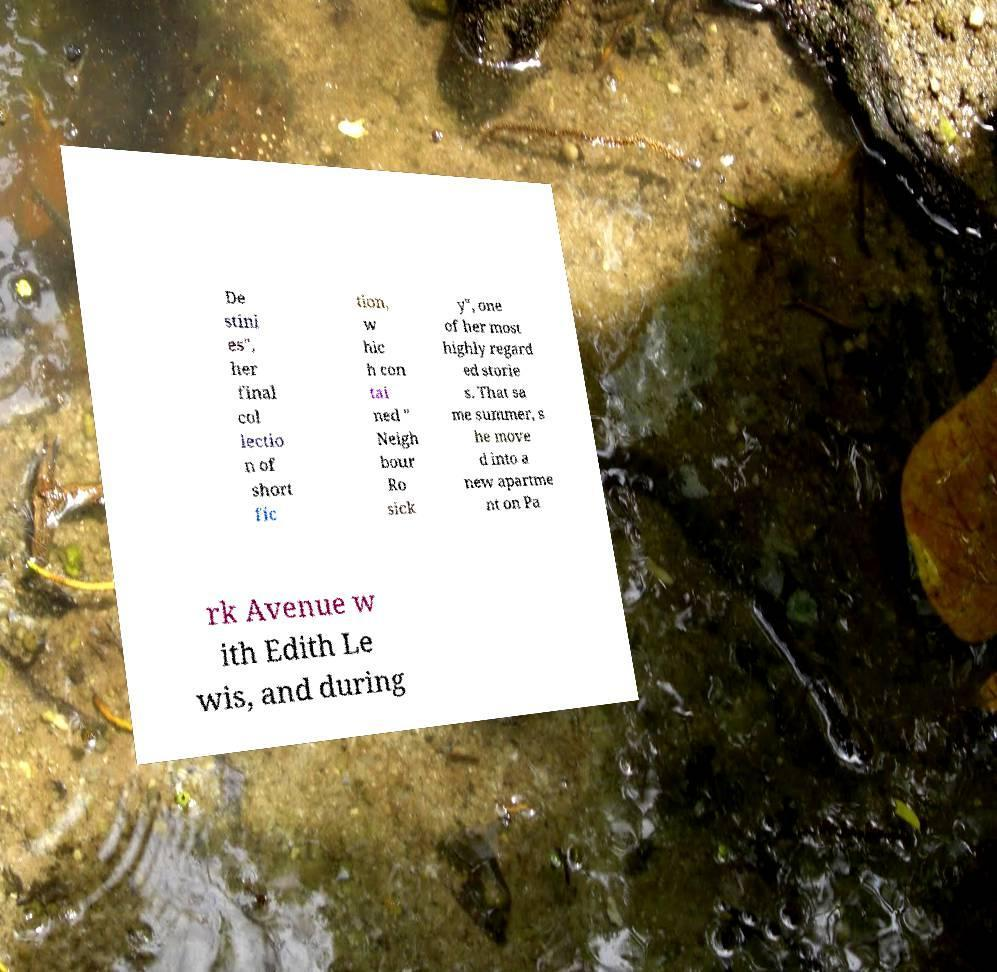Can you accurately transcribe the text from the provided image for me? De stini es", her final col lectio n of short fic tion, w hic h con tai ned " Neigh bour Ro sick y", one of her most highly regard ed storie s. That sa me summer, s he move d into a new apartme nt on Pa rk Avenue w ith Edith Le wis, and during 